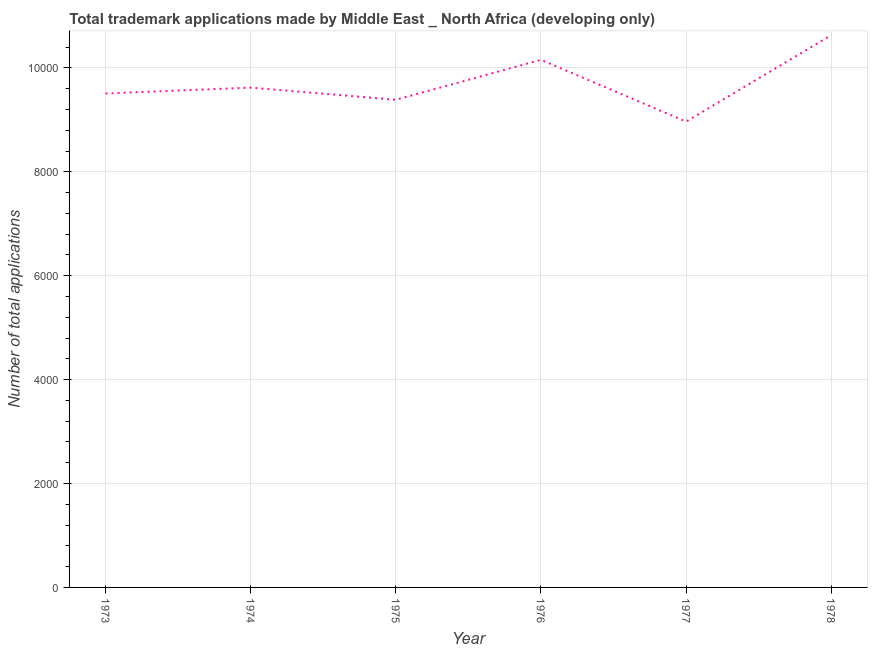What is the number of trademark applications in 1976?
Keep it short and to the point. 1.02e+04. Across all years, what is the maximum number of trademark applications?
Make the answer very short. 1.06e+04. Across all years, what is the minimum number of trademark applications?
Your answer should be very brief. 8966. In which year was the number of trademark applications maximum?
Give a very brief answer. 1978. What is the sum of the number of trademark applications?
Offer a terse response. 5.83e+04. What is the difference between the number of trademark applications in 1974 and 1978?
Provide a succinct answer. -1010. What is the average number of trademark applications per year?
Your response must be concise. 9710.67. What is the median number of trademark applications?
Make the answer very short. 9563.5. In how many years, is the number of trademark applications greater than 2800 ?
Provide a succinct answer. 6. Do a majority of the years between 1975 and 1973 (inclusive) have number of trademark applications greater than 9600 ?
Provide a succinct answer. No. What is the ratio of the number of trademark applications in 1977 to that in 1978?
Make the answer very short. 0.84. Is the difference between the number of trademark applications in 1973 and 1975 greater than the difference between any two years?
Ensure brevity in your answer.  No. What is the difference between the highest and the second highest number of trademark applications?
Make the answer very short. 475. Is the sum of the number of trademark applications in 1974 and 1978 greater than the maximum number of trademark applications across all years?
Offer a terse response. Yes. What is the difference between the highest and the lowest number of trademark applications?
Offer a terse response. 1664. In how many years, is the number of trademark applications greater than the average number of trademark applications taken over all years?
Your answer should be compact. 2. Does the number of trademark applications monotonically increase over the years?
Keep it short and to the point. No. How many lines are there?
Offer a terse response. 1. Are the values on the major ticks of Y-axis written in scientific E-notation?
Give a very brief answer. No. Does the graph contain any zero values?
Your response must be concise. No. Does the graph contain grids?
Provide a succinct answer. Yes. What is the title of the graph?
Offer a very short reply. Total trademark applications made by Middle East _ North Africa (developing only). What is the label or title of the X-axis?
Provide a short and direct response. Year. What is the label or title of the Y-axis?
Keep it short and to the point. Number of total applications. What is the Number of total applications of 1973?
Your answer should be very brief. 9507. What is the Number of total applications in 1974?
Keep it short and to the point. 9620. What is the Number of total applications in 1975?
Keep it short and to the point. 9386. What is the Number of total applications in 1976?
Ensure brevity in your answer.  1.02e+04. What is the Number of total applications in 1977?
Your answer should be compact. 8966. What is the Number of total applications in 1978?
Make the answer very short. 1.06e+04. What is the difference between the Number of total applications in 1973 and 1974?
Make the answer very short. -113. What is the difference between the Number of total applications in 1973 and 1975?
Your response must be concise. 121. What is the difference between the Number of total applications in 1973 and 1976?
Provide a short and direct response. -648. What is the difference between the Number of total applications in 1973 and 1977?
Provide a short and direct response. 541. What is the difference between the Number of total applications in 1973 and 1978?
Keep it short and to the point. -1123. What is the difference between the Number of total applications in 1974 and 1975?
Make the answer very short. 234. What is the difference between the Number of total applications in 1974 and 1976?
Provide a succinct answer. -535. What is the difference between the Number of total applications in 1974 and 1977?
Keep it short and to the point. 654. What is the difference between the Number of total applications in 1974 and 1978?
Keep it short and to the point. -1010. What is the difference between the Number of total applications in 1975 and 1976?
Your answer should be very brief. -769. What is the difference between the Number of total applications in 1975 and 1977?
Your answer should be very brief. 420. What is the difference between the Number of total applications in 1975 and 1978?
Give a very brief answer. -1244. What is the difference between the Number of total applications in 1976 and 1977?
Offer a terse response. 1189. What is the difference between the Number of total applications in 1976 and 1978?
Your response must be concise. -475. What is the difference between the Number of total applications in 1977 and 1978?
Keep it short and to the point. -1664. What is the ratio of the Number of total applications in 1973 to that in 1975?
Give a very brief answer. 1.01. What is the ratio of the Number of total applications in 1973 to that in 1976?
Ensure brevity in your answer.  0.94. What is the ratio of the Number of total applications in 1973 to that in 1977?
Keep it short and to the point. 1.06. What is the ratio of the Number of total applications in 1973 to that in 1978?
Provide a short and direct response. 0.89. What is the ratio of the Number of total applications in 1974 to that in 1975?
Offer a terse response. 1.02. What is the ratio of the Number of total applications in 1974 to that in 1976?
Your answer should be compact. 0.95. What is the ratio of the Number of total applications in 1974 to that in 1977?
Keep it short and to the point. 1.07. What is the ratio of the Number of total applications in 1974 to that in 1978?
Make the answer very short. 0.91. What is the ratio of the Number of total applications in 1975 to that in 1976?
Provide a succinct answer. 0.92. What is the ratio of the Number of total applications in 1975 to that in 1977?
Ensure brevity in your answer.  1.05. What is the ratio of the Number of total applications in 1975 to that in 1978?
Ensure brevity in your answer.  0.88. What is the ratio of the Number of total applications in 1976 to that in 1977?
Give a very brief answer. 1.13. What is the ratio of the Number of total applications in 1976 to that in 1978?
Ensure brevity in your answer.  0.95. What is the ratio of the Number of total applications in 1977 to that in 1978?
Your response must be concise. 0.84. 